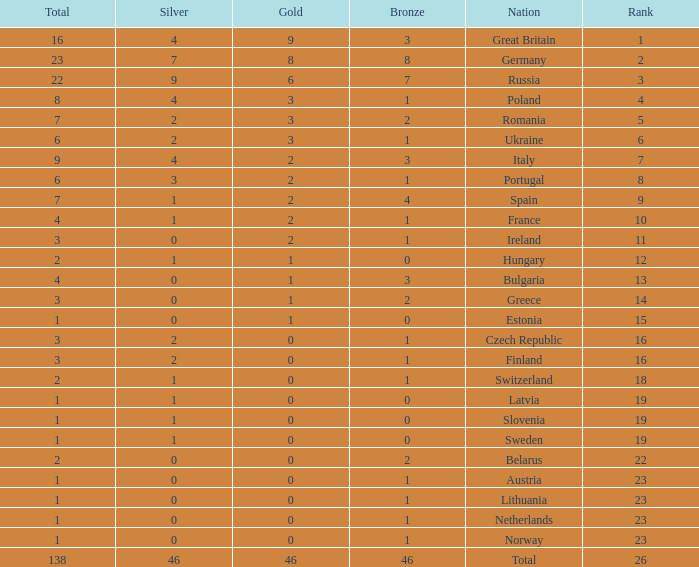What is the total number for a total when the nation is netherlands and silver is larger than 0? 0.0. 